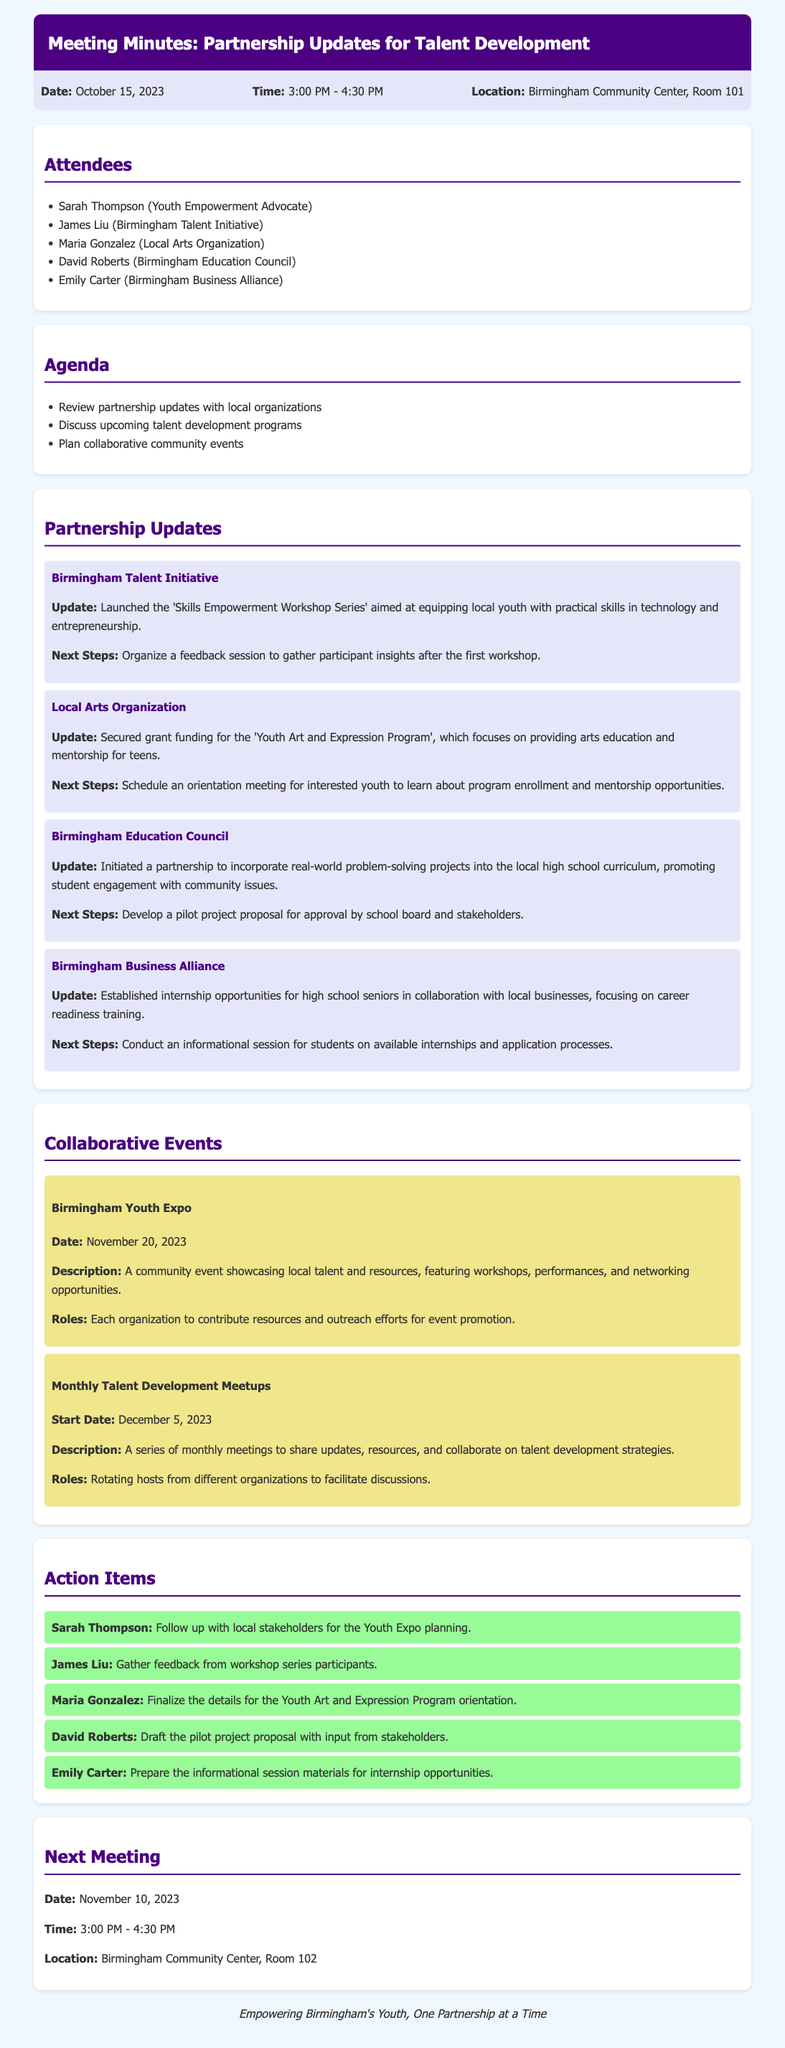What is the date of the meeting? The date is explicitly mentioned at the beginning of the document.
Answer: October 15, 2023 Who is the Youth Empowerment Advocate? The document lists the attendees, and Sarah Thompson is identified as the Youth Empowerment Advocate.
Answer: Sarah Thompson What program did the Birmingham Talent Initiative launch? The partnership update section provides specific names of programs launched by each organization.
Answer: Skills Empowerment Workshop Series When is the Birmingham Youth Expo scheduled? The specific date for the Birmingham Youth Expo is given under the collaborative events section.
Answer: November 20, 2023 What is the main focus of the Youth Art and Expression Program? The update mentions the primary goal of the program, providing arts education and mentorship.
Answer: Arts education and mentorship What will be discussed in the Monthly Talent Development Meetups? The description in the collaborative events section outlines the purpose of these meetings.
Answer: Updates, resources, and talent development strategies Who will finalize the details for the Youth Art and Expression Program orientation? The action items section assigns tasks to individuals, indicating who is responsible for various actions.
Answer: Maria Gonzalez What room number is the next meeting scheduled to be held in? The next meeting details include the specific room indicated at the end of the document.
Answer: Room 102 